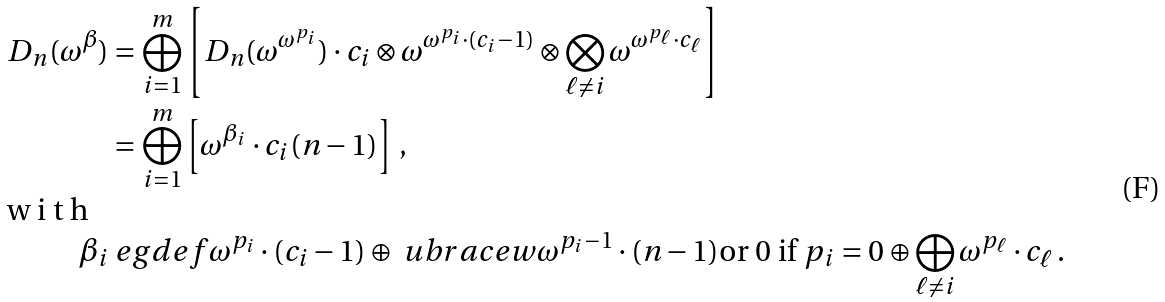Convert formula to latex. <formula><loc_0><loc_0><loc_500><loc_500>D _ { n } ( \omega ^ { \beta } ) & = \bigoplus _ { i = 1 } ^ { m } \left [ D _ { n } ( \omega ^ { \omega ^ { p _ { i } } } ) \cdot c _ { i } \otimes \omega ^ { \omega ^ { p _ { i } } \cdot ( c _ { i } - 1 ) } \otimes \bigotimes _ { \ell \neq i } \omega ^ { \omega ^ { p _ { \ell } } \cdot c _ { \ell } } \right ] \\ & = \bigoplus _ { i = 1 } ^ { m } \left [ \omega ^ { \beta _ { i } } \cdot c _ { i } ( n - 1 ) \right ] \, , \\ \shortintertext { w i t h } \beta _ { i } & \ e g d e f \omega ^ { p _ { i } } \cdot ( c _ { i } - 1 ) \oplus \ u b r a c e w { \omega ^ { p _ { i } - 1 } \cdot ( n - 1 ) } { \text {or $0$ if $p_{i}=0$} } \oplus \bigoplus _ { \ell \not = i } \omega ^ { p _ { \ell } } \cdot c _ { \ell } \, .</formula> 